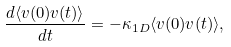<formula> <loc_0><loc_0><loc_500><loc_500>\frac { d \langle v ( 0 ) v ( t ) \rangle } { d t } = - \kappa _ { 1 D } \langle v ( 0 ) v ( t ) \rangle ,</formula> 